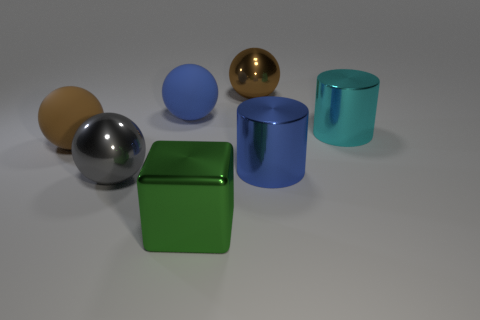What number of large brown balls have the same material as the gray object?
Ensure brevity in your answer.  1. What number of big balls are in front of the matte sphere that is right of the gray sphere?
Offer a very short reply. 2. There is a shiny sphere in front of the brown shiny ball; is its color the same as the metallic cylinder behind the blue metal thing?
Offer a very short reply. No. What shape is the object that is on the right side of the green shiny cube and in front of the cyan object?
Provide a short and direct response. Cylinder. Is there a small blue metallic thing of the same shape as the gray thing?
Make the answer very short. No. What is the shape of the brown matte object that is the same size as the green metal block?
Offer a very short reply. Sphere. What is the material of the large gray thing?
Keep it short and to the point. Metal. What size is the thing on the right side of the metal cylinder in front of the brown thing that is in front of the large cyan shiny object?
Give a very brief answer. Large. What number of rubber objects are tiny green blocks or large brown balls?
Provide a short and direct response. 1. What is the size of the brown shiny ball?
Offer a terse response. Large. 